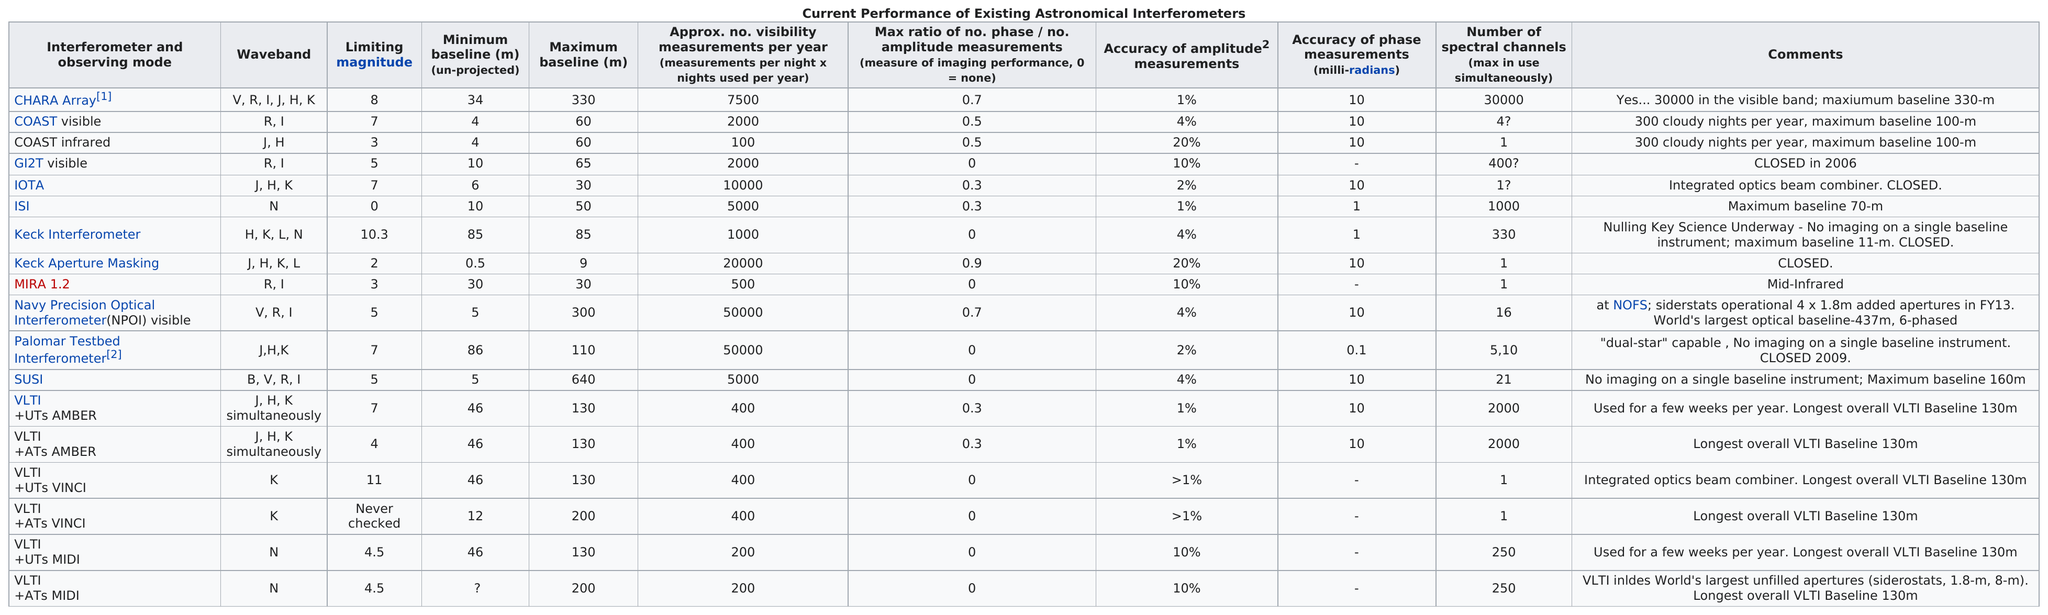Specify some key components in this picture. The number of entries in the dataset that have an accuracy of phase measurements (milliradians) no greater than 0.1, up to a maximum of 1. The total limiting magnitude of coast visible and coast infrared is 10. The SUSI interferometer has the highest maximum baseline among all interferometers. According to the available data, 5 interferometers have comments stating that they are closed. The CHARA Array has a limiting magnitude that is higher than what is visible to the naked eye, while the CHARA Array can detect the presence of light in both visible and infrared wavelengths. 